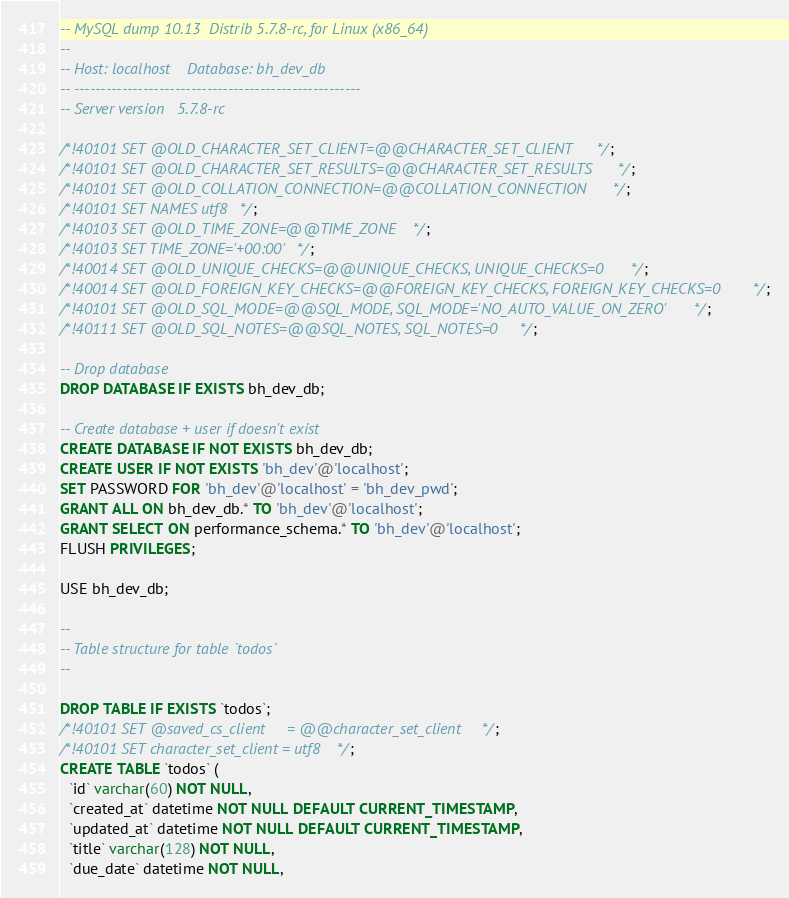Convert code to text. <code><loc_0><loc_0><loc_500><loc_500><_SQL_>-- MySQL dump 10.13  Distrib 5.7.8-rc, for Linux (x86_64)
--
-- Host: localhost    Database: bh_dev_db
-- ------------------------------------------------------
-- Server version	5.7.8-rc

/*!40101 SET @OLD_CHARACTER_SET_CLIENT=@@CHARACTER_SET_CLIENT */;
/*!40101 SET @OLD_CHARACTER_SET_RESULTS=@@CHARACTER_SET_RESULTS */;
/*!40101 SET @OLD_COLLATION_CONNECTION=@@COLLATION_CONNECTION */;
/*!40101 SET NAMES utf8 */;
/*!40103 SET @OLD_TIME_ZONE=@@TIME_ZONE */;
/*!40103 SET TIME_ZONE='+00:00' */;
/*!40014 SET @OLD_UNIQUE_CHECKS=@@UNIQUE_CHECKS, UNIQUE_CHECKS=0 */;
/*!40014 SET @OLD_FOREIGN_KEY_CHECKS=@@FOREIGN_KEY_CHECKS, FOREIGN_KEY_CHECKS=0 */;
/*!40101 SET @OLD_SQL_MODE=@@SQL_MODE, SQL_MODE='NO_AUTO_VALUE_ON_ZERO' */;
/*!40111 SET @OLD_SQL_NOTES=@@SQL_NOTES, SQL_NOTES=0 */;

-- Drop database
DROP DATABASE IF EXISTS bh_dev_db;

-- Create database + user if doesn't exist
CREATE DATABASE IF NOT EXISTS bh_dev_db;
CREATE USER IF NOT EXISTS 'bh_dev'@'localhost';
SET PASSWORD FOR 'bh_dev'@'localhost' = 'bh_dev_pwd';
GRANT ALL ON bh_dev_db.* TO 'bh_dev'@'localhost';
GRANT SELECT ON performance_schema.* TO 'bh_dev'@'localhost';
FLUSH PRIVILEGES;

USE bh_dev_db;

--
-- Table structure for table `todos`
--

DROP TABLE IF EXISTS `todos`;
/*!40101 SET @saved_cs_client     = @@character_set_client */;
/*!40101 SET character_set_client = utf8 */;
CREATE TABLE `todos` (
  `id` varchar(60) NOT NULL,
  `created_at` datetime NOT NULL DEFAULT CURRENT_TIMESTAMP,
  `updated_at` datetime NOT NULL DEFAULT CURRENT_TIMESTAMP,
  `title` varchar(128) NOT NULL,
  `due_date` datetime NOT NULL,</code> 